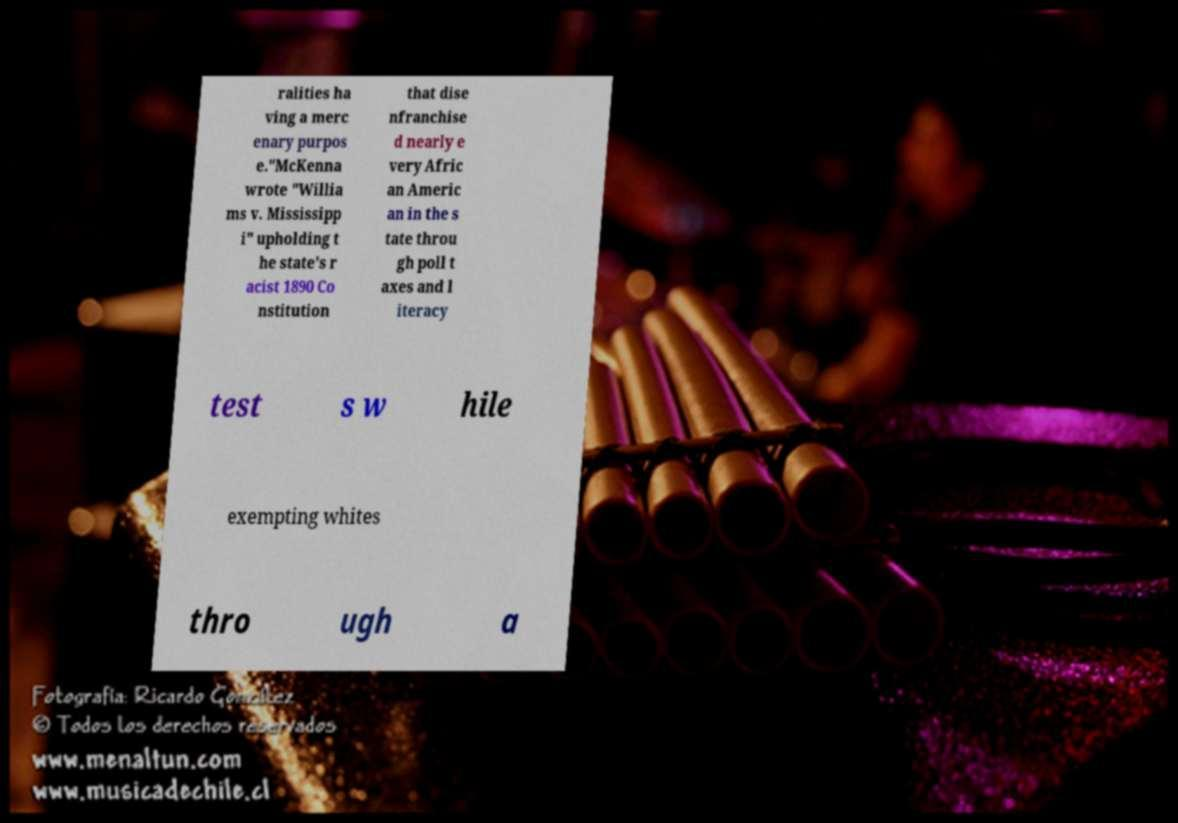Please read and relay the text visible in this image. What does it say? ralities ha ving a merc enary purpos e."McKenna wrote "Willia ms v. Mississipp i" upholding t he state's r acist 1890 Co nstitution that dise nfranchise d nearly e very Afric an Americ an in the s tate throu gh poll t axes and l iteracy test s w hile exempting whites thro ugh a 